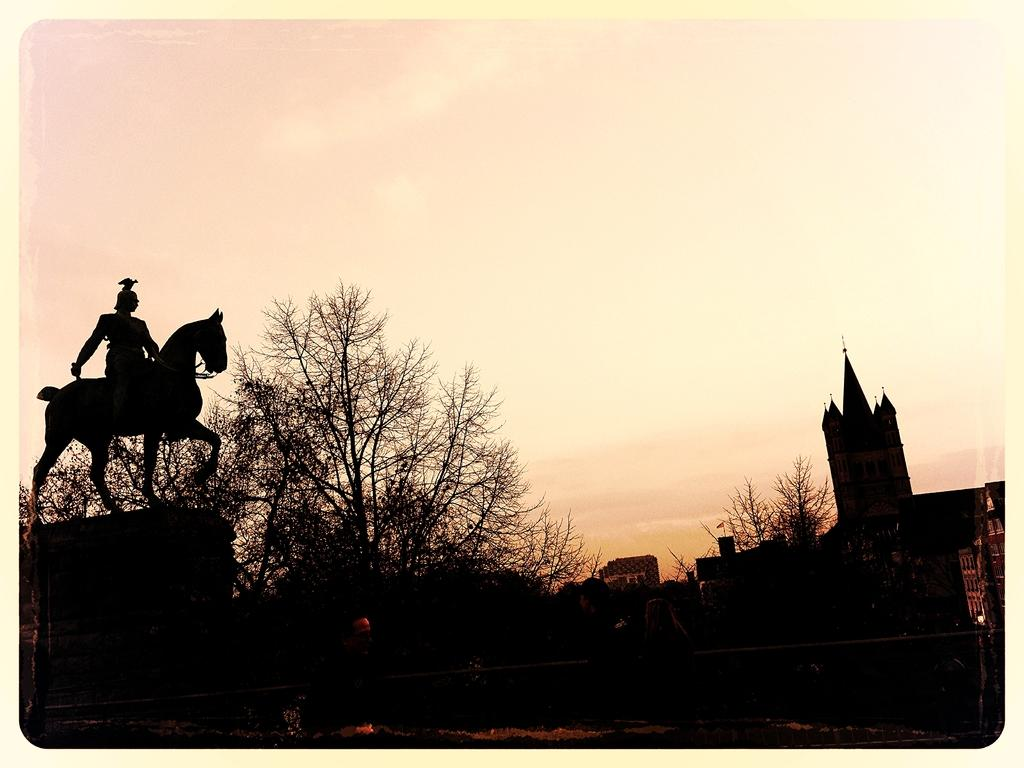What is the lighting condition of the front of the image? The front of the image is dark. What is the main subject of the sculpture in the image? The sculpture is of a person sitting on a horse. What type of natural elements can be seen in the image? Trees are visible in the image. What type of man-made structures are present in the image? Buildings are present in the image. What is visible in the background of the image? The sky is visible in the background of the image. What type of opinion can be seen expressed by the eggs in the image? There are no eggs present in the image, so no opinion can be expressed by them. What type of apple is being used as a prop in the image? There is no apple present in the image. 